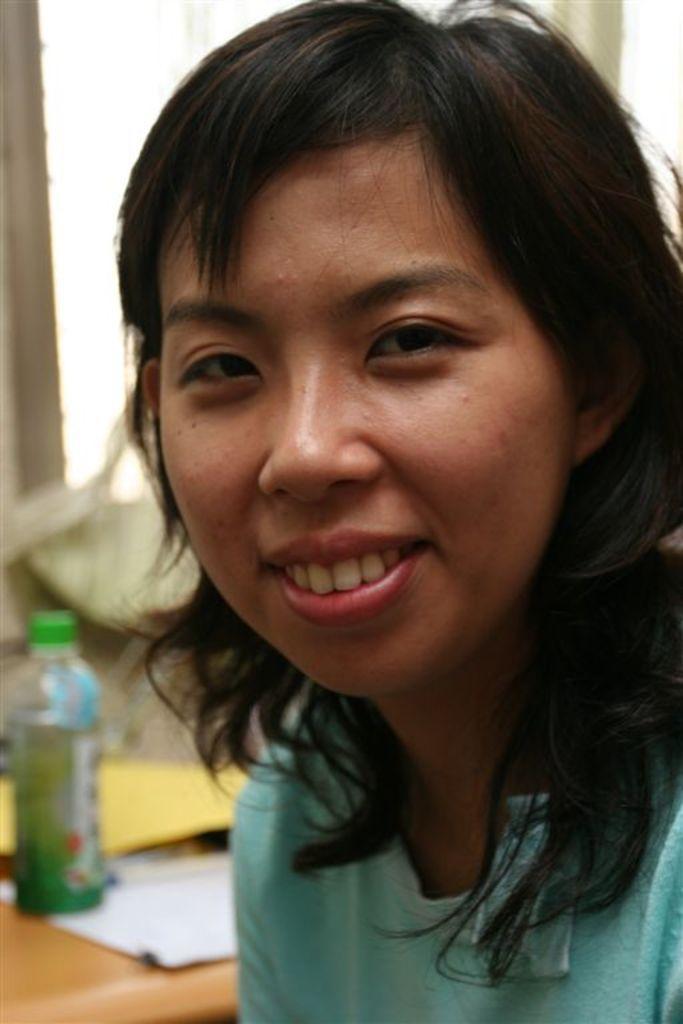Please provide a concise description of this image. In this picture we can see women wore T-Shirt and smiling and in background we can see bottle, paper on table, window. 